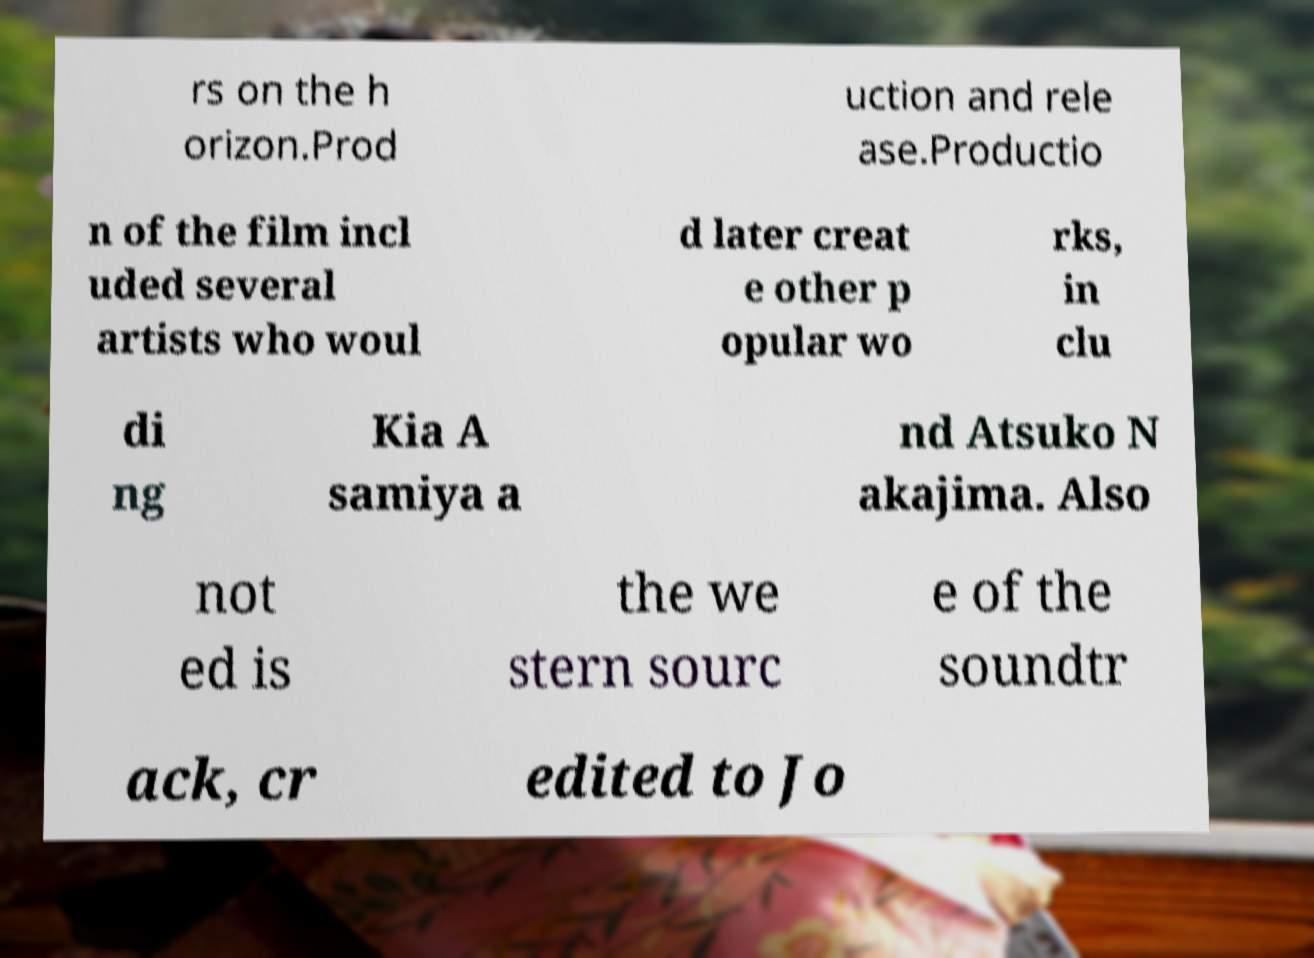For documentation purposes, I need the text within this image transcribed. Could you provide that? rs on the h orizon.Prod uction and rele ase.Productio n of the film incl uded several artists who woul d later creat e other p opular wo rks, in clu di ng Kia A samiya a nd Atsuko N akajima. Also not ed is the we stern sourc e of the soundtr ack, cr edited to Jo 